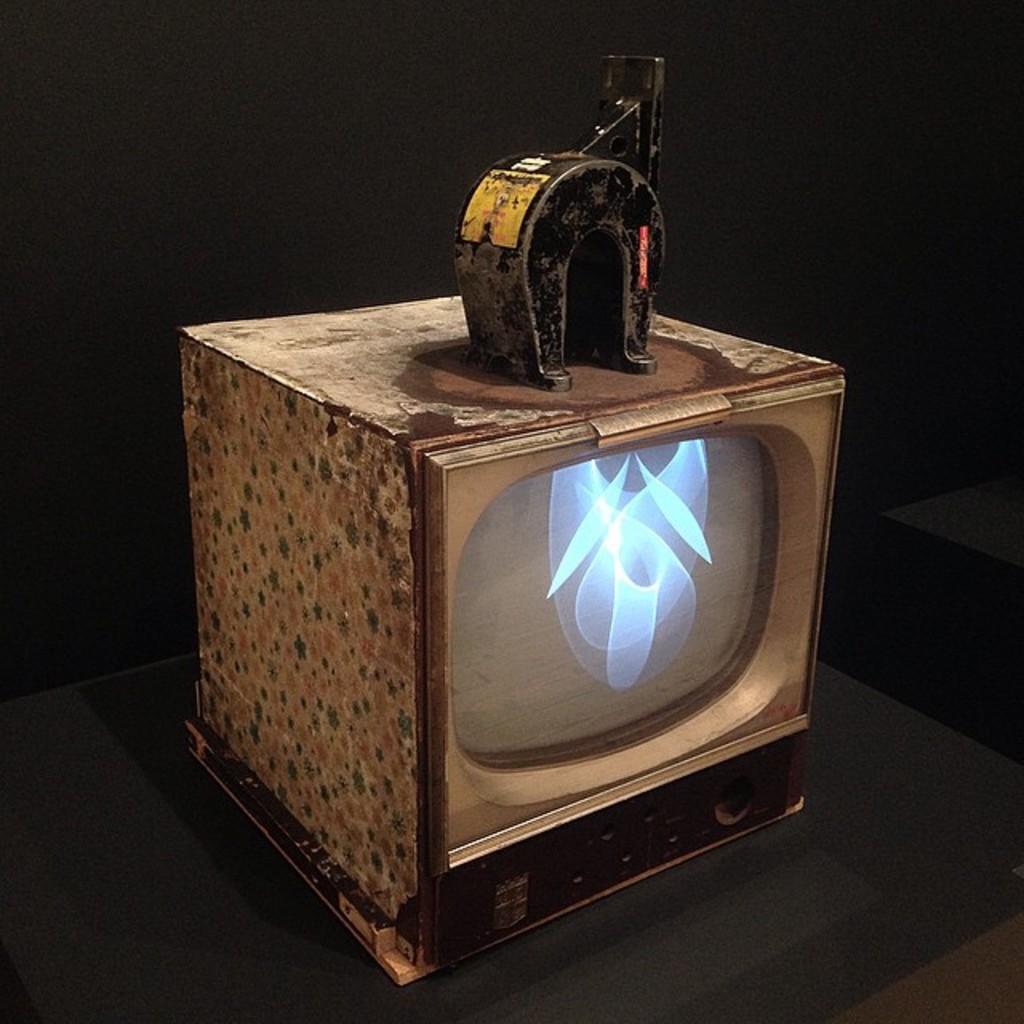Can you describe this image briefly? In this picture, it looks like an old television and at the top of the television there is an iron object. Behind the television, there is the dark background. 